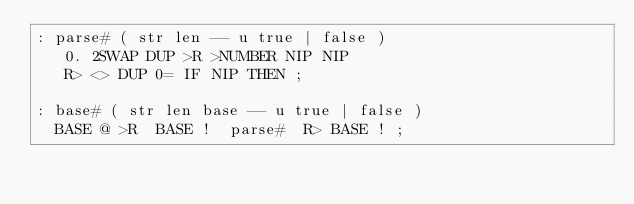Convert code to text. <code><loc_0><loc_0><loc_500><loc_500><_Forth_>: parse# ( str len -- u true | false )
   0. 2SWAP DUP >R >NUMBER NIP NIP
   R> <> DUP 0= IF NIP THEN ;

: base# ( str len base -- u true | false )
  BASE @ >R  BASE !  parse#  R> BASE ! ;
</code> 